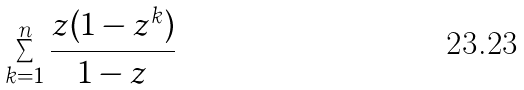<formula> <loc_0><loc_0><loc_500><loc_500>\sum _ { k = 1 } ^ { n } \frac { z ( 1 - z ^ { k } ) } { 1 - z }</formula> 